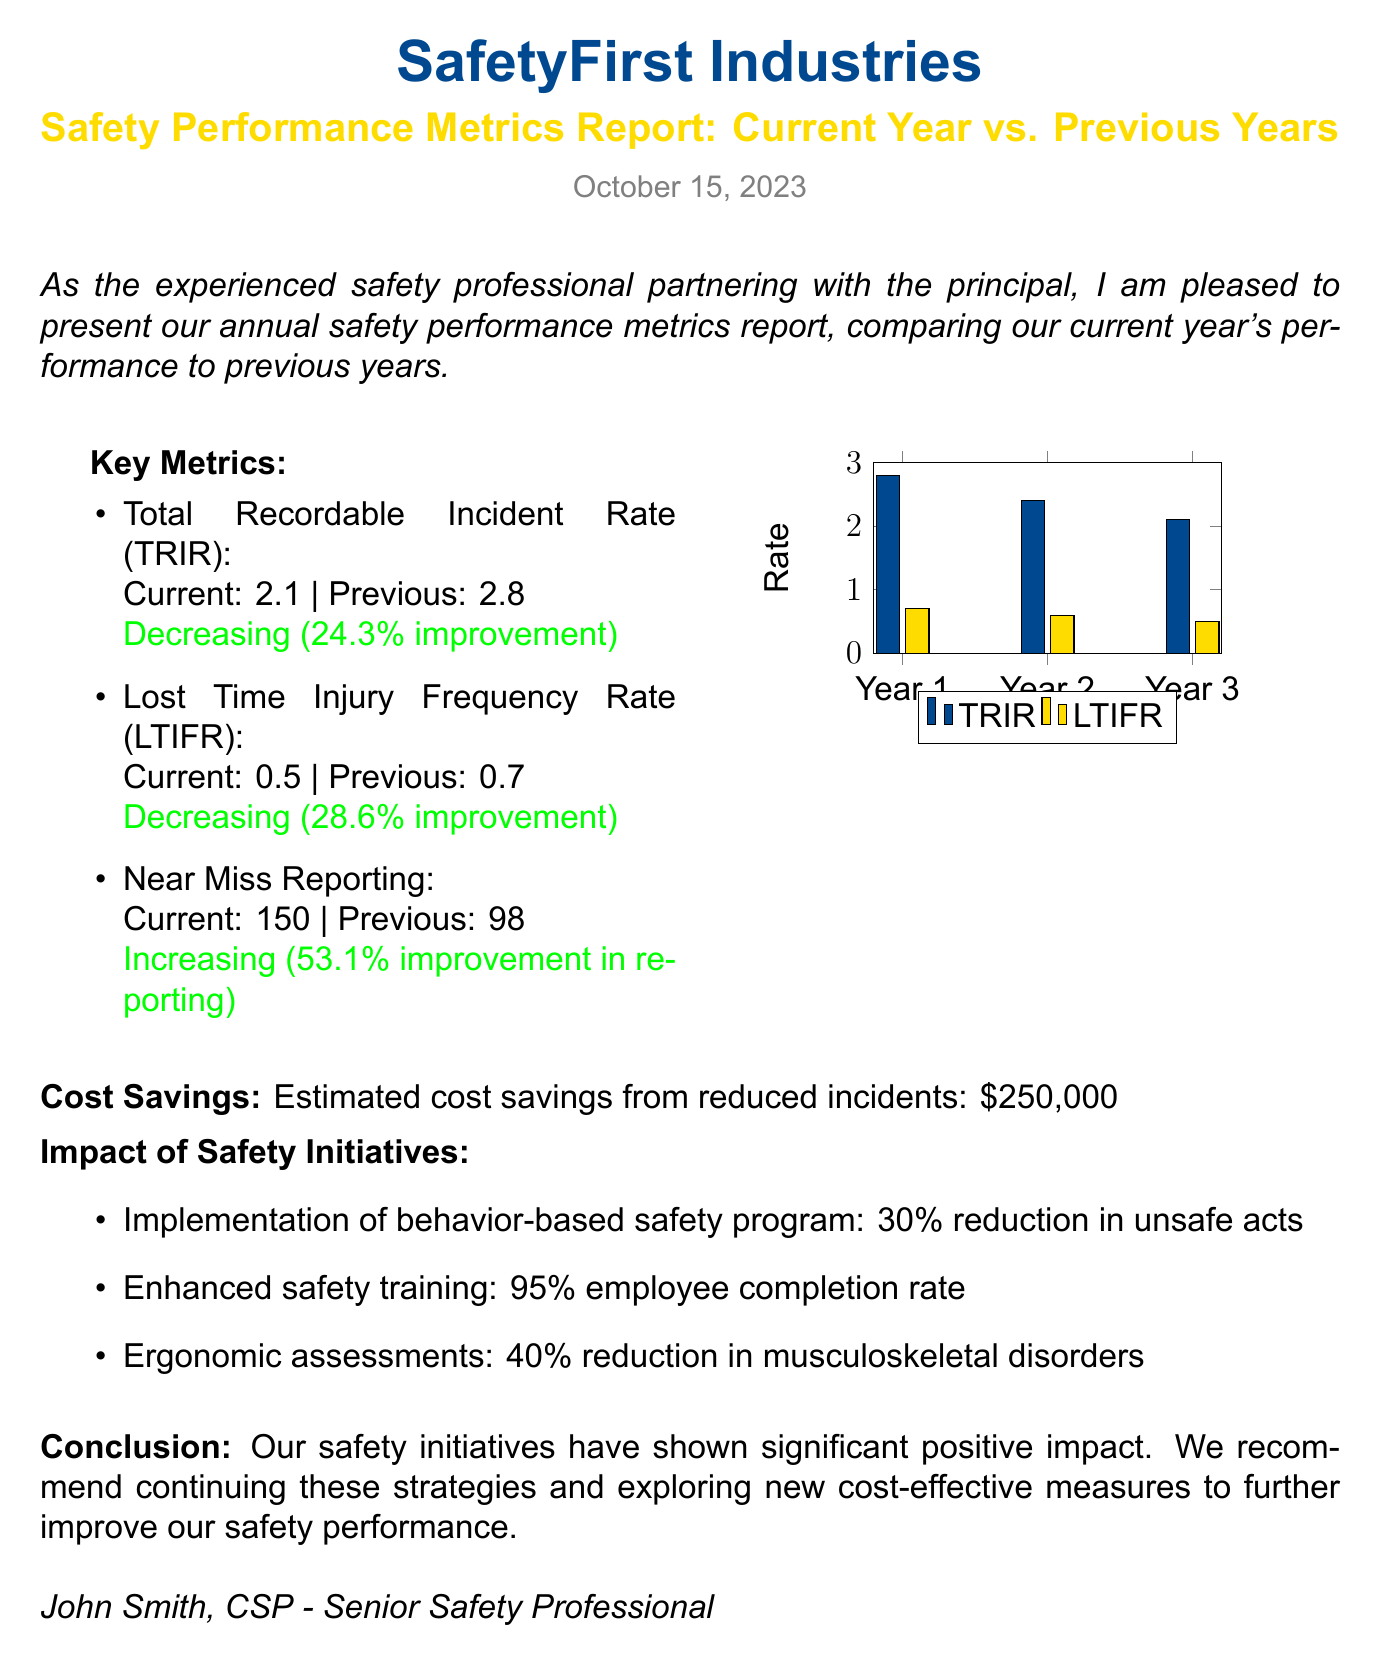What is the current Total Recordable Incident Rate (TRIR)? The current TRIR is directly mentioned in the key metrics section of the report.
Answer: 2.1 What is the previous Lost Time Injury Frequency Rate (LTIFR)? The report states the previous LTIFR in the key metrics section for comparison.
Answer: 0.7 What is the percentage improvement in Near Miss Reporting? The document indicates the percentage improvement in reporting near misses as part of the key metrics.
Answer: 53.1% What were the estimated cost savings from reduced incidents? The report highlights the estimated cost savings resulting from a decrease in incidents.
Answer: $250,000 What is the completion rate for enhanced safety training? The report mentions the employee completion rate for safety training as part of the impact of safety initiatives.
Answer: 95% How much reduction in unsafe acts resulted from the behavior-based safety program? The impact of the safety initiatives describes the reduction in unsafe acts.
Answer: 30% Which color represents TRIR in the graph? The graph in the document uses specific colors to differentiate between metrics.
Answer: Safety blue What is the conclusion about the safety initiatives? The document concludes with a summary of the effectiveness of the safety initiatives.
Answer: Significant positive impact What was the TRIR in Year 2? The report provides specific annual rates in the bar graph for comparative analysis.
Answer: 2.4 What is the main focus of the document? The overall purpose is clearly stated at the beginning and can be summed up in one phrase.
Answer: Safety performance metrics report 